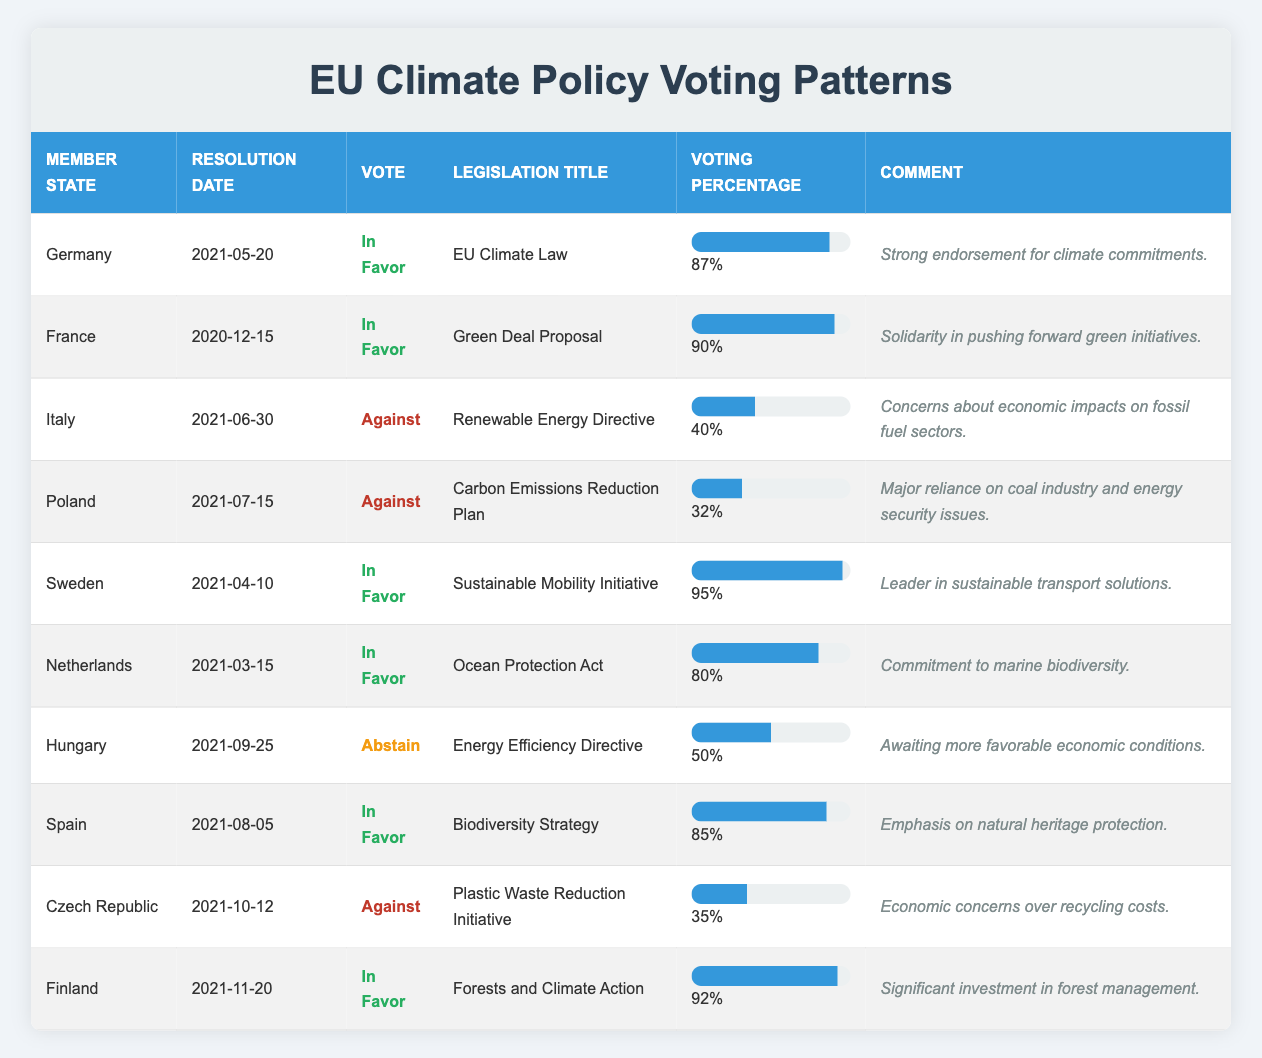What percentage of votes in favor did Finland receive for the Forests and Climate Action legislation? From the table, Finland voted in favor of the Forests and Climate Action legislation, and the voting percentage is listed as 92%.
Answer: 92% Which country had the least support for its climate legislation? Looking at the voting percentages, Poland had the lowest support with a voting percentage of 32% for the Carbon Emissions Reduction Plan.
Answer: Poland How many countries voted against climate legislation? The table shows that Italy, Poland, Czech Republic each voted against a specific legislation, totaling three countries.
Answer: 3 What was the average voting percentage for the countries voting in favor? The voting percentages for countries voting in favor are 87, 90, 95, 80, 85, 92. Summing these gives 87 + 90 + 95 + 80 + 85 + 92 = 519. There are 6 countries, so the average is 519 / 6 = 86.5.
Answer: 86.5 Did Hungary vote in favor of any climate legislation? Hungary is listed as abstaining on the Energy Efficiency Directive, which means it did not vote in favor or against.
Answer: No Which country showed the strongest endorsement for climate commitments? Germany had an 87% voting percentage for the EU Climate Law and a comment indicating strong endorsement for climate commitments, thus the answer is Germany.
Answer: Germany What is the difference in voting percentage between the highest and lowest in favor votes? The highest in favor voting percentage is 95% from Sweden and the lowest is 80% from the Netherlands. The difference is 95 - 80 = 15%.
Answer: 15% Did any country abstain from voting completely? Looking at the table, Hungary is the only country that abstained, indicating it did not vote in favor or against any legislation.
Answer: Yes Which legislation had the highest voting percentage and which country supported it? The legislation with the highest voting percentage is the Sustainable Mobility Initiative with 95%, supported by Sweden according to the table.
Answer: Sweden for Sustainable Mobility Initiative What percentage of countries opposed climate change initiatives out of the total surveyed? Out of 10 member states, 3 voted against climate change (Italy, Poland, Czech Republic). Thus, to find the percentage, we calculate (3/10)*100 = 30%.
Answer: 30% 